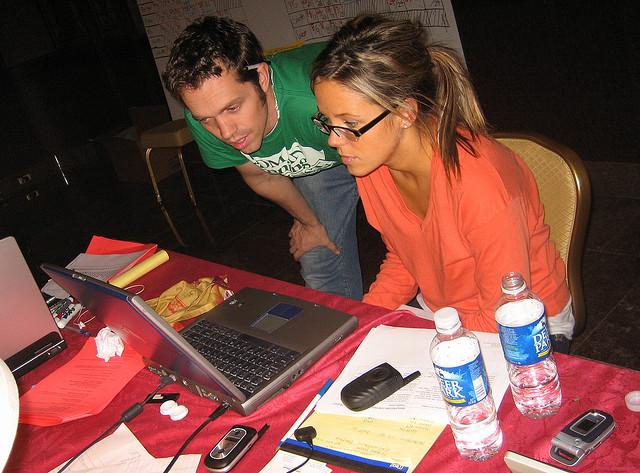Which person is sitting?
Answer briefly. Girl. How many cell phones are on the table?
Quick response, please. 3. How many asians are at the table?
Concise answer only. 0. Who made the water?
Give a very brief answer. Deer park. How many blue bottles are on the table?
Concise answer only. 2. What is wrapped in the napkin to the right of the picture?
Give a very brief answer. Nothing. 